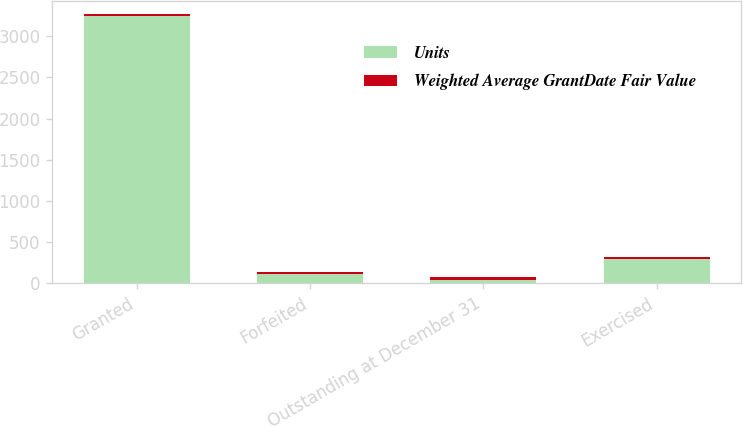Convert chart to OTSL. <chart><loc_0><loc_0><loc_500><loc_500><stacked_bar_chart><ecel><fcel>Granted<fcel>Forfeited<fcel>Outstanding at December 31<fcel>Exercised<nl><fcel>Units<fcel>3246<fcel>106<fcel>36.67<fcel>286<nl><fcel>Weighted Average GrantDate Fair Value<fcel>25.45<fcel>25.54<fcel>34.64<fcel>26.66<nl></chart> 